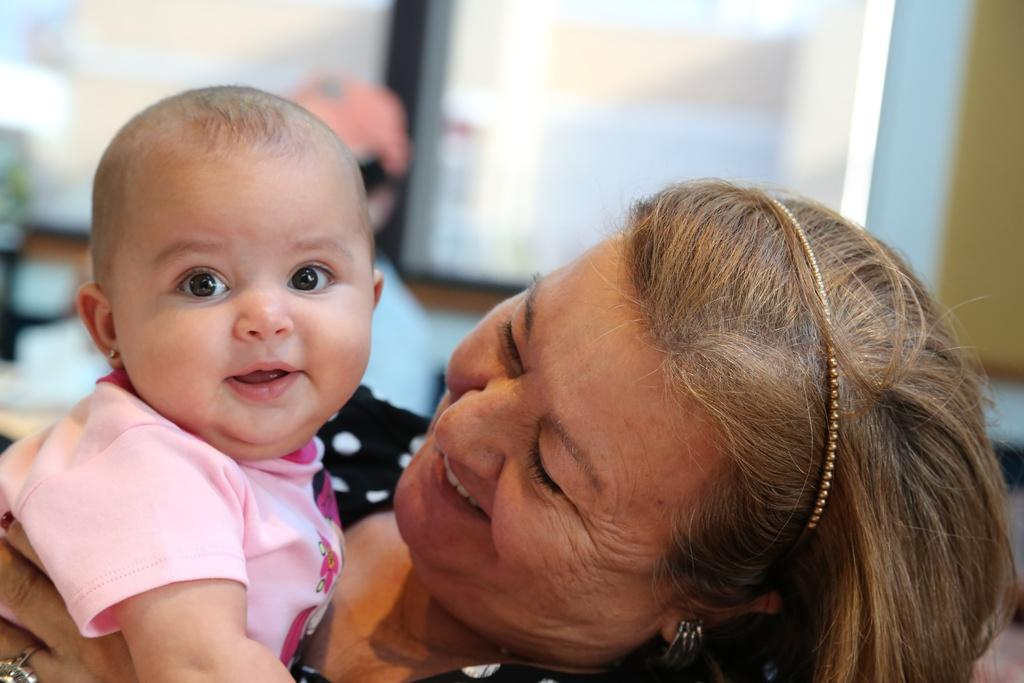Who or what can be seen in the image? There are people in the image. Can you describe the background of the image? The background of the image is blurred. What type of silk material is draped over the floor in the image? There is no silk material or floor visible in the image; it only features people with a blurred background. 